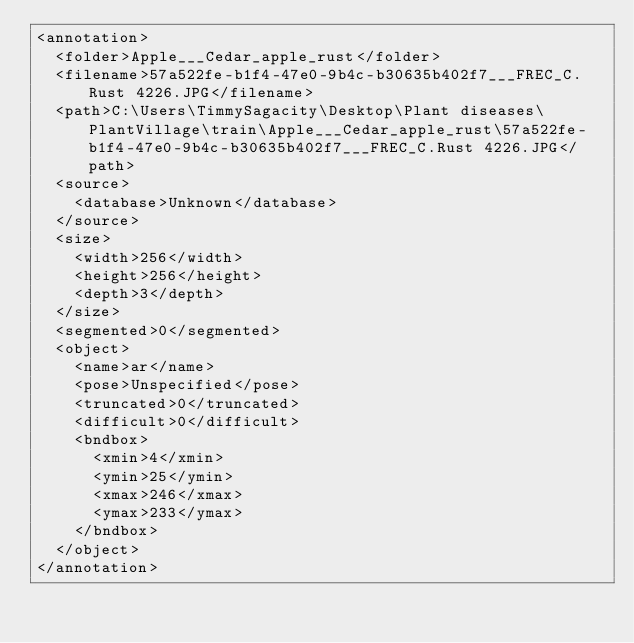Convert code to text. <code><loc_0><loc_0><loc_500><loc_500><_XML_><annotation>
	<folder>Apple___Cedar_apple_rust</folder>
	<filename>57a522fe-b1f4-47e0-9b4c-b30635b402f7___FREC_C.Rust 4226.JPG</filename>
	<path>C:\Users\TimmySagacity\Desktop\Plant diseases\PlantVillage\train\Apple___Cedar_apple_rust\57a522fe-b1f4-47e0-9b4c-b30635b402f7___FREC_C.Rust 4226.JPG</path>
	<source>
		<database>Unknown</database>
	</source>
	<size>
		<width>256</width>
		<height>256</height>
		<depth>3</depth>
	</size>
	<segmented>0</segmented>
	<object>
		<name>ar</name>
		<pose>Unspecified</pose>
		<truncated>0</truncated>
		<difficult>0</difficult>
		<bndbox>
			<xmin>4</xmin>
			<ymin>25</ymin>
			<xmax>246</xmax>
			<ymax>233</ymax>
		</bndbox>
	</object>
</annotation>
</code> 